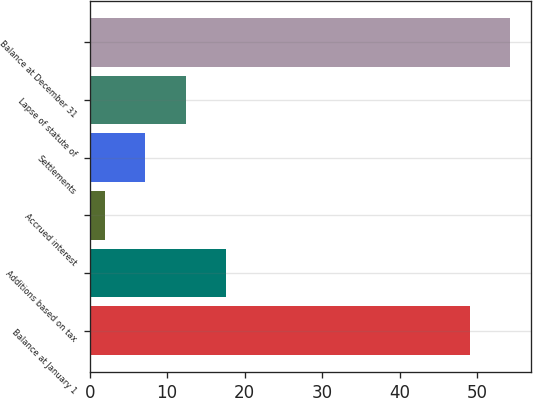Convert chart to OTSL. <chart><loc_0><loc_0><loc_500><loc_500><bar_chart><fcel>Balance at January 1<fcel>Additions based on tax<fcel>Accrued interest<fcel>Settlements<fcel>Lapse of statute of<fcel>Balance at December 31<nl><fcel>49<fcel>17.6<fcel>2<fcel>7.2<fcel>12.4<fcel>54.2<nl></chart> 